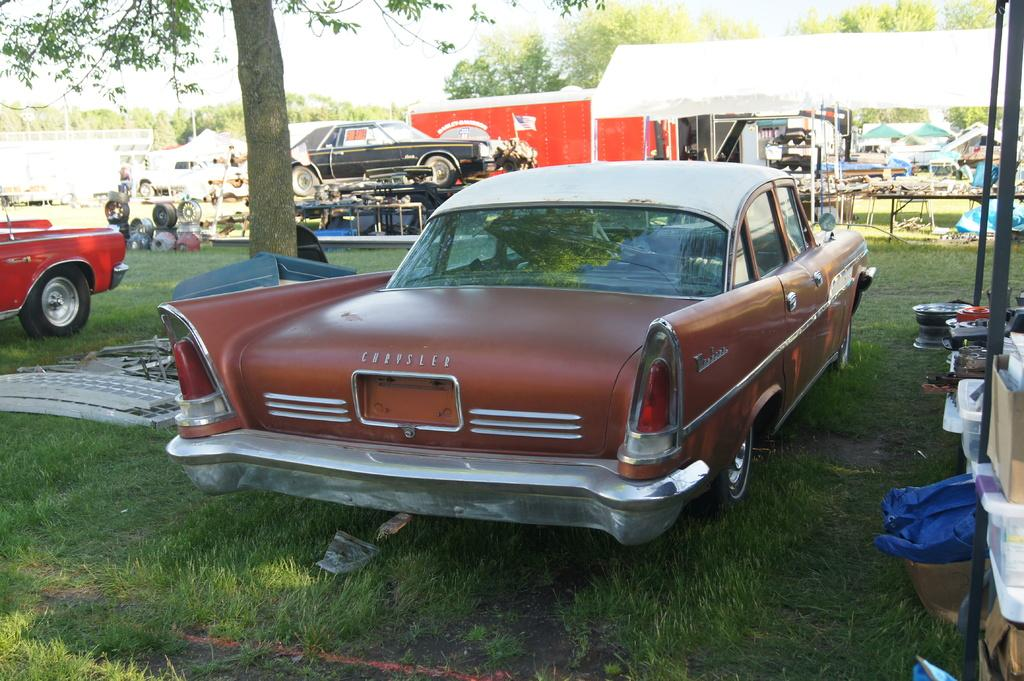What type of surface are the cars placed on in the image? The cars are on the grass floor in the image. What can be seen in the background of the image? There are trees around the area in the image. What objects are present on the tables in the image? There are items placed on the tables in the image. What type of structure is visible in the image? There is a shed in the image. What color is the sock hanging from the tree in the image? There is no sock hanging from the tree in the image. Is the stove used for cooking in the image? There is no stove present in the image. 